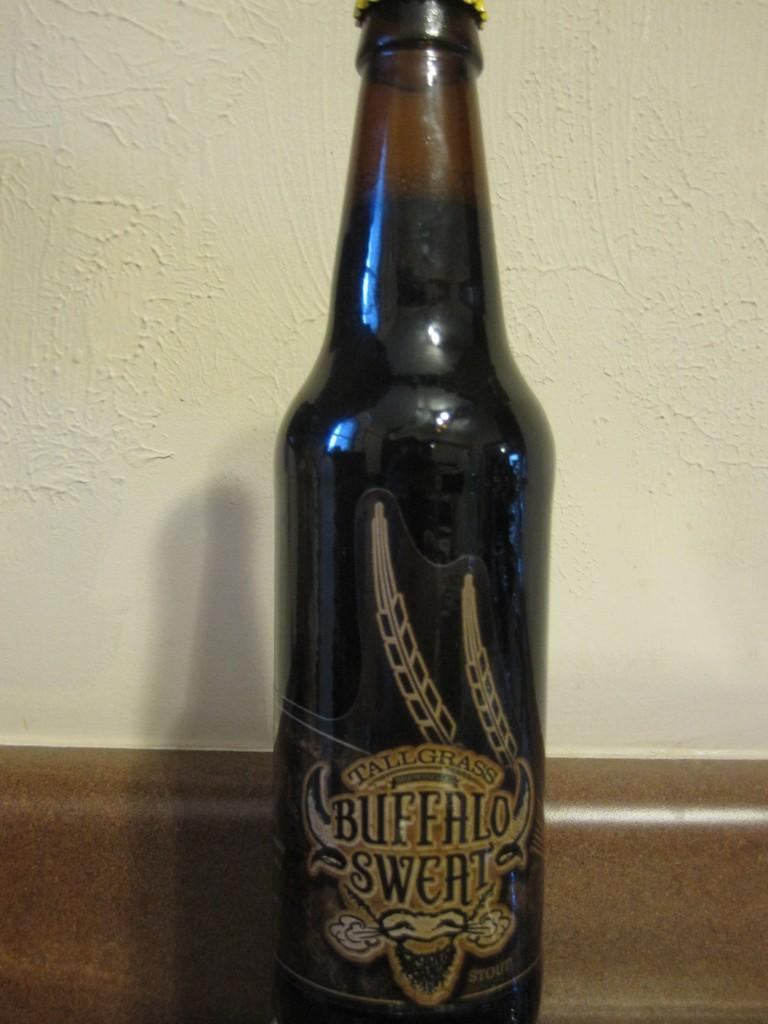<image>
Offer a succinct explanation of the picture presented. An old bottle of Tallgrass Buffalo Sweat has been pushed against the wall 